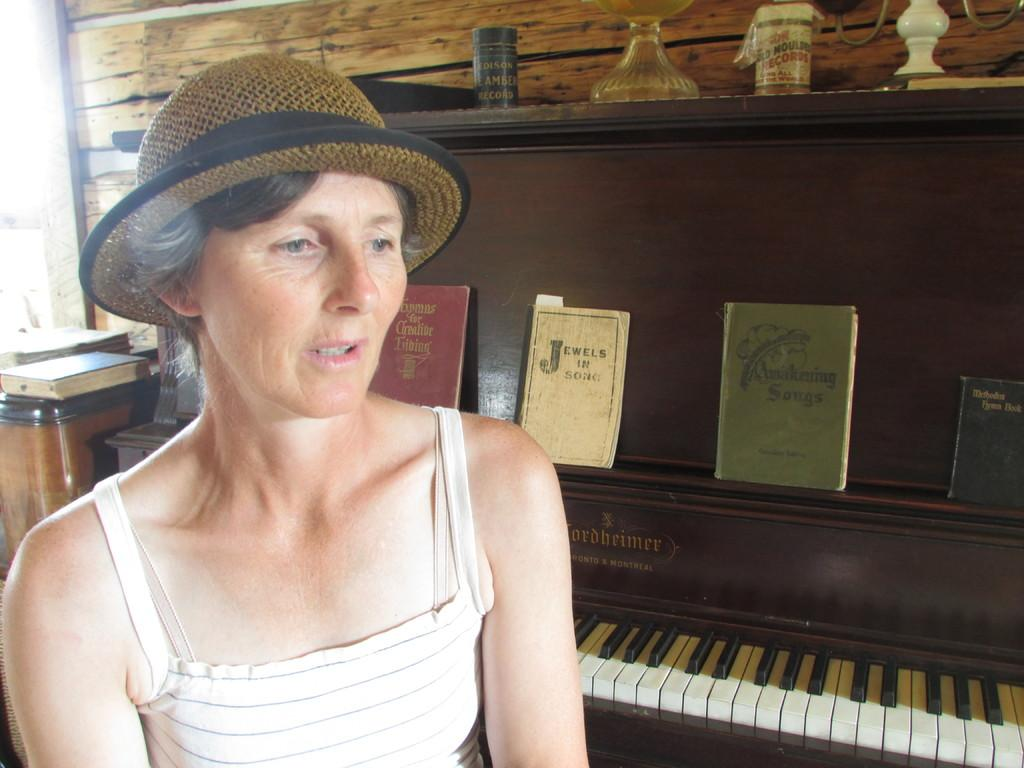Who is present in the image? There is a woman in the image. What is the woman wearing on her head? The woman is wearing a hat. What musical instrument can be seen in the image? There is a piano in the image. What is placed on top of the piano? There are books and other things on the piano. What type of stem can be seen growing from the woman's hat in the image? There is no stem growing from the woman's hat in the image. How many cherries are on the piano in the image? There are no cherries present in the image. 